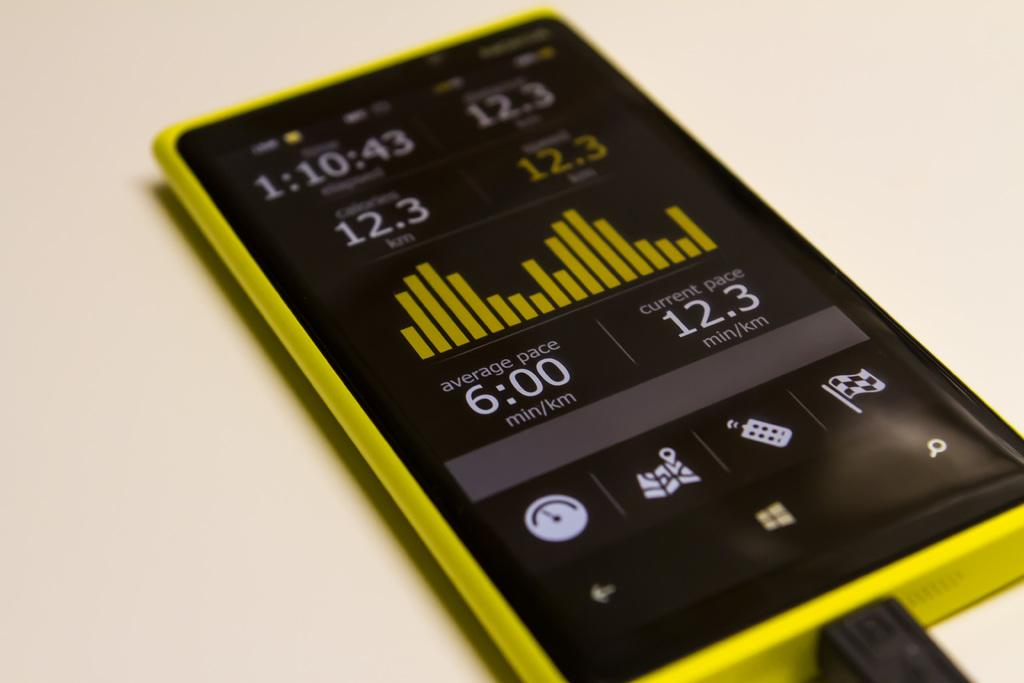<image>
Present a compact description of the photo's key features. Yellow and black cellphone that says 6:00 min on the screen. 